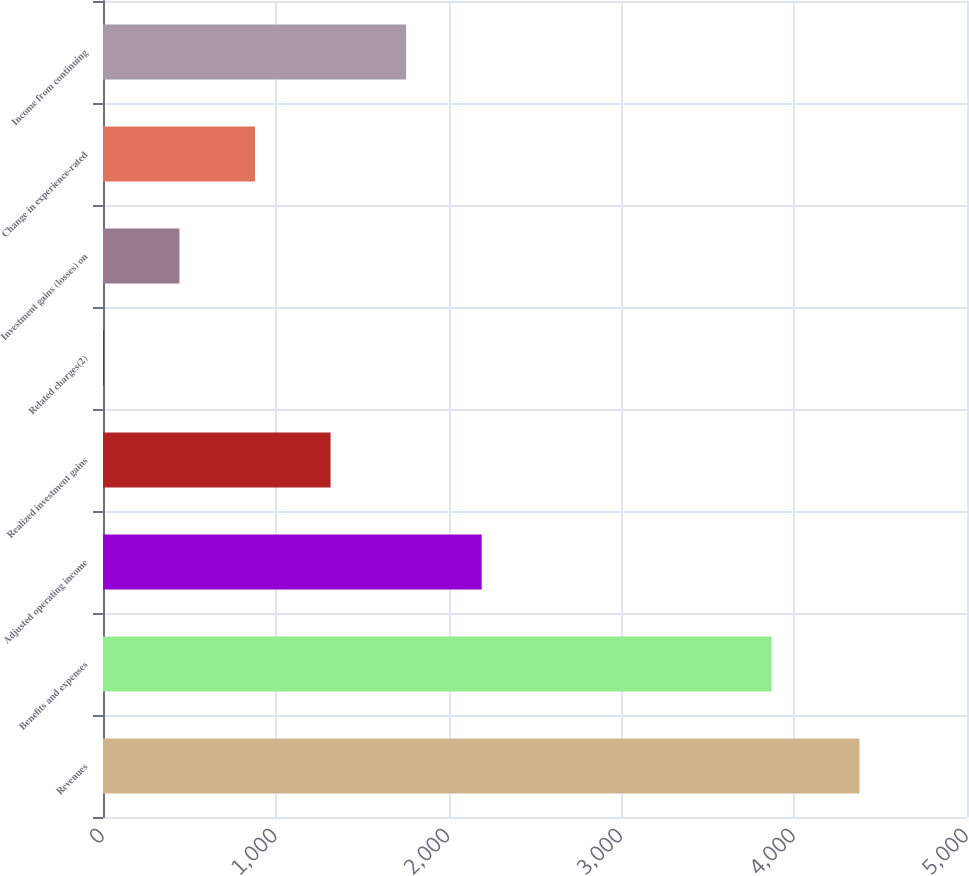Convert chart to OTSL. <chart><loc_0><loc_0><loc_500><loc_500><bar_chart><fcel>Revenues<fcel>Benefits and expenses<fcel>Adjusted operating income<fcel>Realized investment gains<fcel>Related charges(2)<fcel>Investment gains (losses) on<fcel>Change in experience-rated<fcel>Income from continuing<nl><fcel>4378<fcel>3869<fcel>2191.5<fcel>1316.9<fcel>5<fcel>442.3<fcel>879.6<fcel>1754.2<nl></chart> 